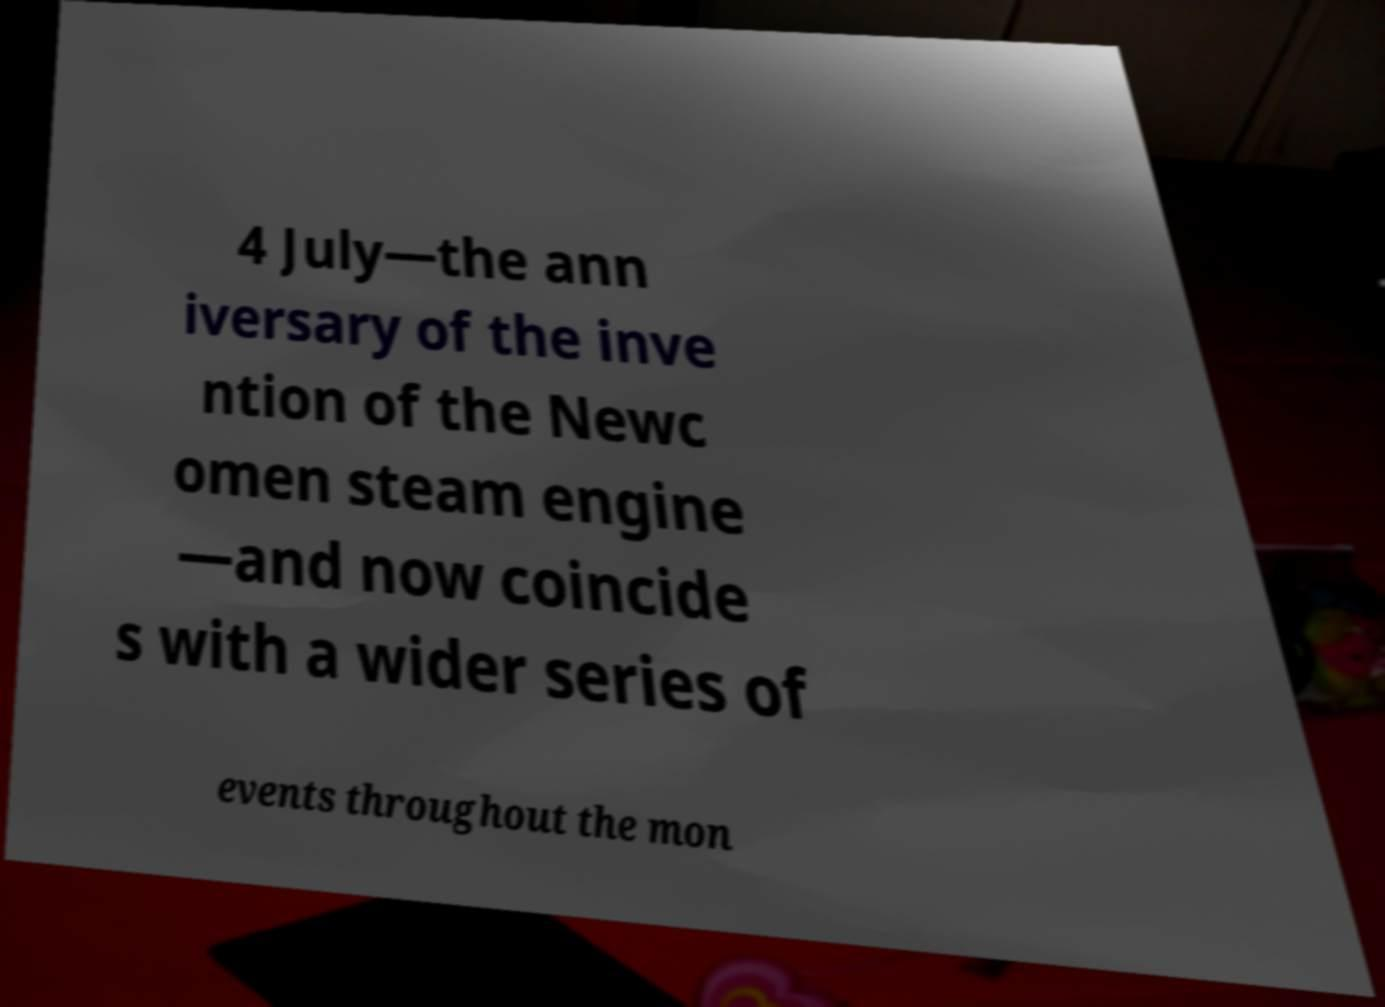Please identify and transcribe the text found in this image. 4 July—the ann iversary of the inve ntion of the Newc omen steam engine —and now coincide s with a wider series of events throughout the mon 